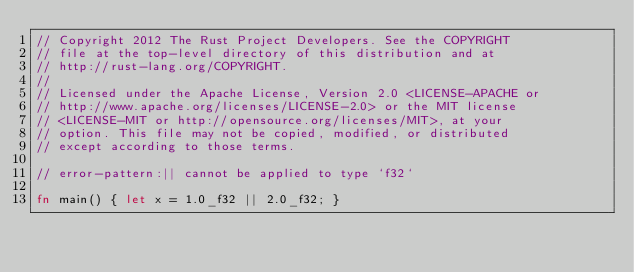<code> <loc_0><loc_0><loc_500><loc_500><_Rust_>// Copyright 2012 The Rust Project Developers. See the COPYRIGHT
// file at the top-level directory of this distribution and at
// http://rust-lang.org/COPYRIGHT.
//
// Licensed under the Apache License, Version 2.0 <LICENSE-APACHE or
// http://www.apache.org/licenses/LICENSE-2.0> or the MIT license
// <LICENSE-MIT or http://opensource.org/licenses/MIT>, at your
// option. This file may not be copied, modified, or distributed
// except according to those terms.

// error-pattern:|| cannot be applied to type `f32`

fn main() { let x = 1.0_f32 || 2.0_f32; }
</code> 